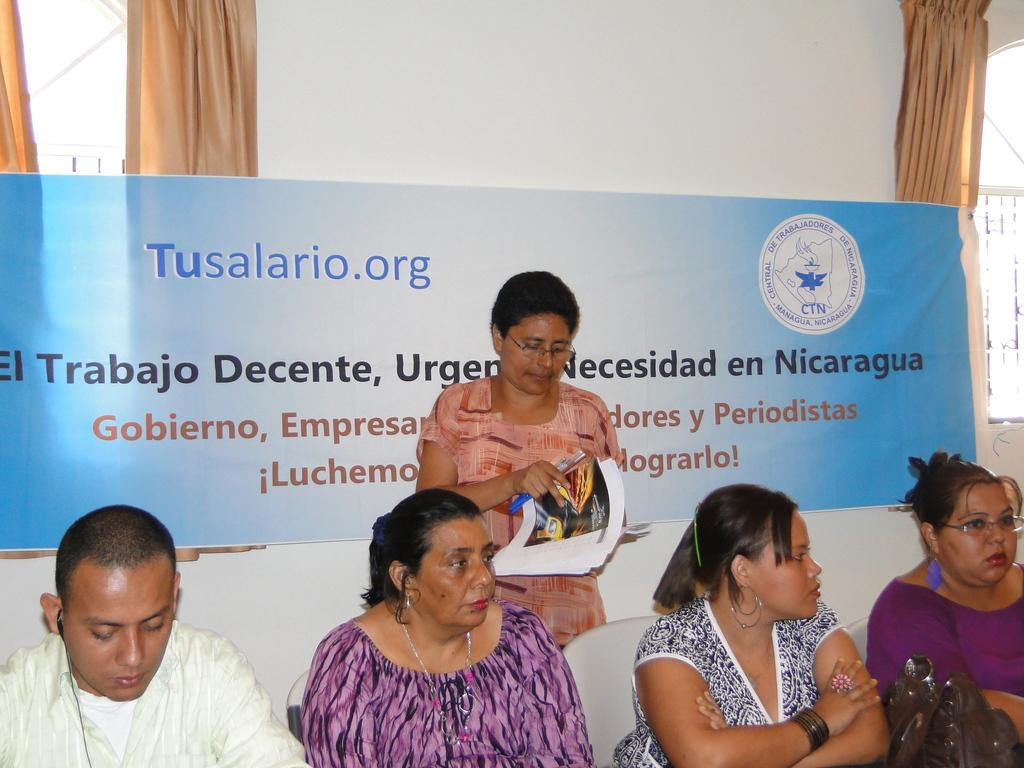Could you give a brief overview of what you see in this image? At the bottom of the image, we can see the bag and four persons are sitting. In the background, there are chairs, wall, windows, curtains and banner. In the middle of the image, we can see a person standing in-front of a banner and holding few objects. 